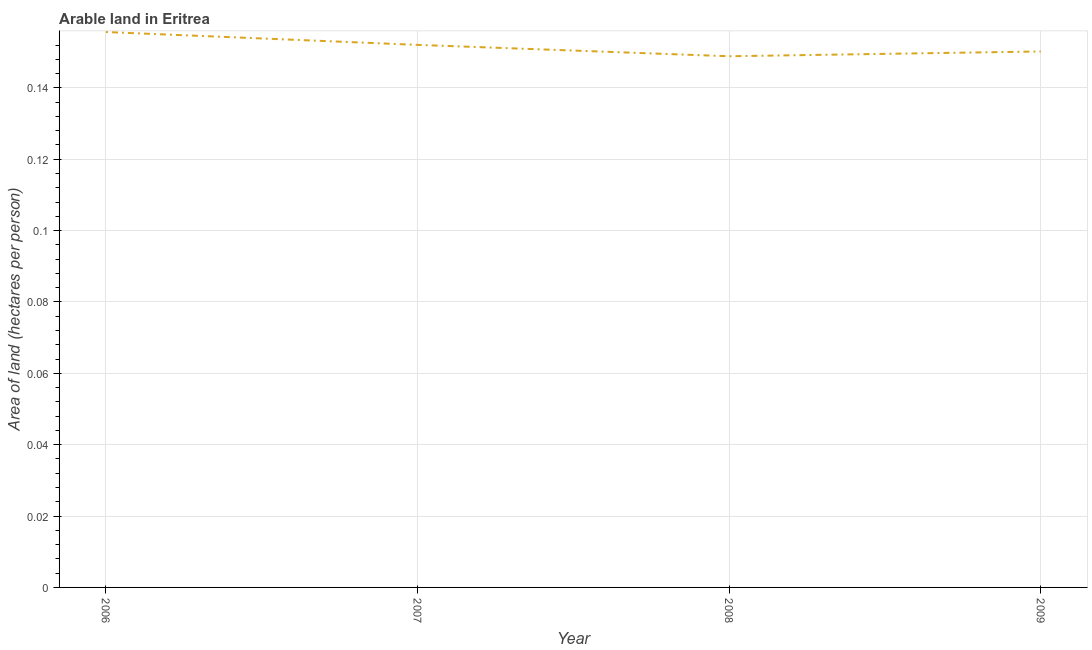What is the area of arable land in 2006?
Provide a succinct answer. 0.16. Across all years, what is the maximum area of arable land?
Keep it short and to the point. 0.16. Across all years, what is the minimum area of arable land?
Offer a terse response. 0.15. In which year was the area of arable land maximum?
Your response must be concise. 2006. What is the sum of the area of arable land?
Provide a short and direct response. 0.61. What is the difference between the area of arable land in 2006 and 2008?
Make the answer very short. 0.01. What is the average area of arable land per year?
Your response must be concise. 0.15. What is the median area of arable land?
Your response must be concise. 0.15. In how many years, is the area of arable land greater than 0.14 hectares per person?
Your answer should be very brief. 4. What is the ratio of the area of arable land in 2008 to that in 2009?
Provide a succinct answer. 0.99. What is the difference between the highest and the second highest area of arable land?
Provide a succinct answer. 0. What is the difference between the highest and the lowest area of arable land?
Keep it short and to the point. 0.01. In how many years, is the area of arable land greater than the average area of arable land taken over all years?
Keep it short and to the point. 2. How many lines are there?
Your response must be concise. 1. How many years are there in the graph?
Ensure brevity in your answer.  4. What is the difference between two consecutive major ticks on the Y-axis?
Offer a very short reply. 0.02. Does the graph contain any zero values?
Provide a succinct answer. No. Does the graph contain grids?
Give a very brief answer. Yes. What is the title of the graph?
Your answer should be compact. Arable land in Eritrea. What is the label or title of the X-axis?
Keep it short and to the point. Year. What is the label or title of the Y-axis?
Provide a short and direct response. Area of land (hectares per person). What is the Area of land (hectares per person) of 2006?
Keep it short and to the point. 0.16. What is the Area of land (hectares per person) in 2007?
Give a very brief answer. 0.15. What is the Area of land (hectares per person) in 2008?
Ensure brevity in your answer.  0.15. What is the Area of land (hectares per person) in 2009?
Make the answer very short. 0.15. What is the difference between the Area of land (hectares per person) in 2006 and 2007?
Your answer should be very brief. 0. What is the difference between the Area of land (hectares per person) in 2006 and 2008?
Your answer should be compact. 0.01. What is the difference between the Area of land (hectares per person) in 2006 and 2009?
Provide a succinct answer. 0.01. What is the difference between the Area of land (hectares per person) in 2007 and 2008?
Your response must be concise. 0. What is the difference between the Area of land (hectares per person) in 2007 and 2009?
Give a very brief answer. 0. What is the difference between the Area of land (hectares per person) in 2008 and 2009?
Make the answer very short. -0. What is the ratio of the Area of land (hectares per person) in 2006 to that in 2008?
Your answer should be compact. 1.05. What is the ratio of the Area of land (hectares per person) in 2006 to that in 2009?
Offer a terse response. 1.04. What is the ratio of the Area of land (hectares per person) in 2007 to that in 2008?
Your answer should be very brief. 1.02. What is the ratio of the Area of land (hectares per person) in 2007 to that in 2009?
Offer a terse response. 1.01. What is the ratio of the Area of land (hectares per person) in 2008 to that in 2009?
Offer a terse response. 0.99. 